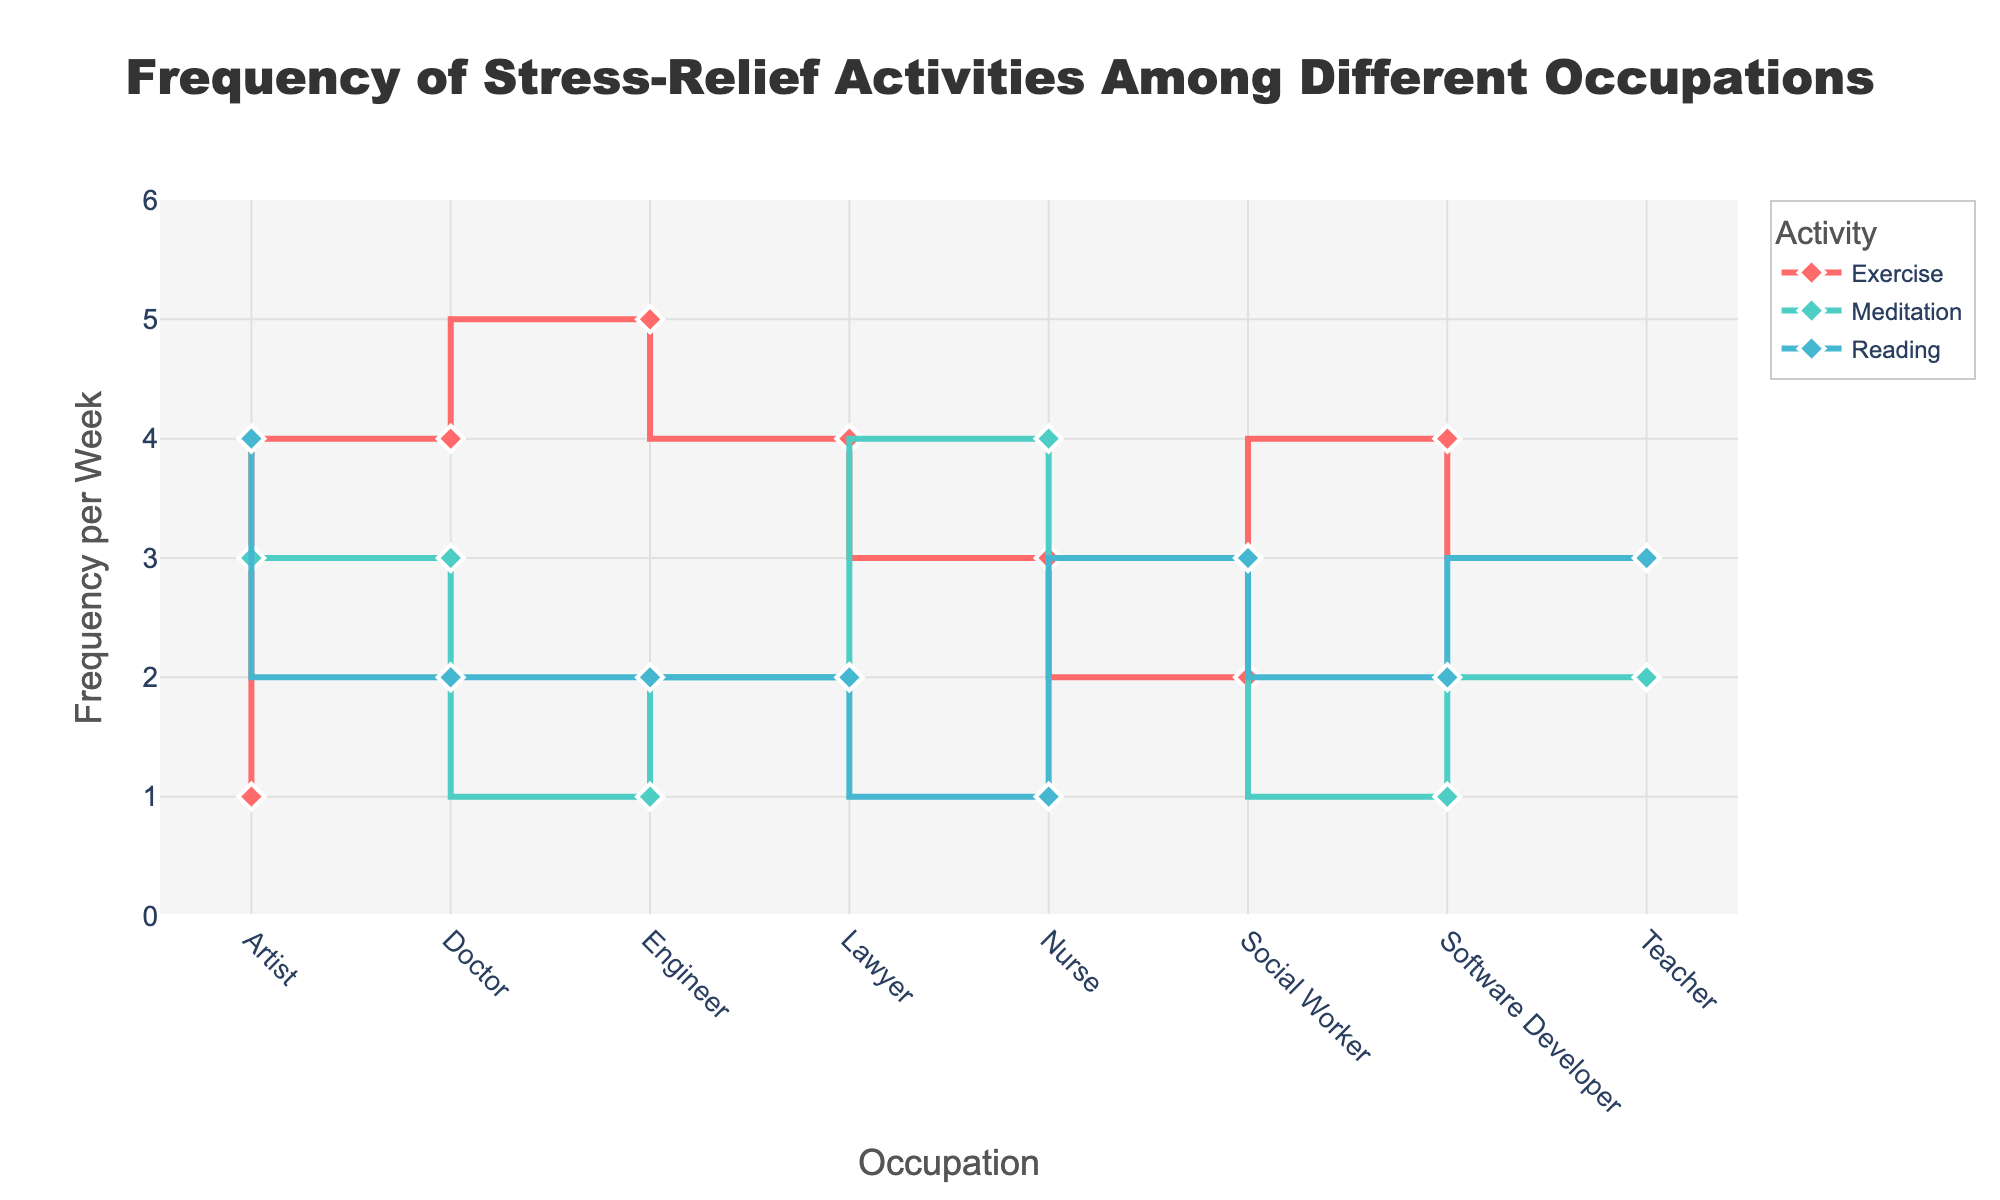what is the title of the figure? The title is usually located at the top of the figure and summarises the presented data.
Answer: Frequency of Stress-Relief Activities Among Different Occupations how many activities are tracked in the figure? By observing the legend, we can count the number of different colors and markers represented. There are three color-coded lines, corresponding to three activities.
Answer: Three what is the highest frequency of meditation for any occupation shown in the figure? By looking at the y-axis values for Meditation traces, the highest point corresponds to the nurse occupation.
Answer: Four times per week which occupation has the lowest frequency of exercise? We follow the exercise trace, and the occupation 'Artist' has the lowest value.
Answer: Artist what is the range of frequencies for reading among all occupations? The y-axis values for reading range from the lowest point of 1 (for Nurse) to a high point of 4 (for Artist).
Answer: 1 to 4 times per week who exercises more frequently, doctors or engineers? By comparing the Exercise trace for Doctor (4 times) and Engineer (5 times), Engineers have a higher frequency.
Answer: Engineers which occupation shows exactly the same frequency for both meditation and reading? By comparing the meditation and reading traces vertically aligned for each occupation, we find that Lawyers have 2 times per week for both activities.
Answer: Lawyers what is the average frequency of exercise across all occupations? Summing the exercise values for all occupations (4 + 3 + 5 + 3 + 4 + 2 + 4 + 1) and dividing by 8 occupations give us the average: (26 / 8 = 3.25).
Answer: 3.25 times per week if you sum the frequencies of meditation and reading for doctors, what total do you get? The frequency for meditation is 3 and for reading is 2. Summing these: 3 + 2 = 5
Answer: Five 